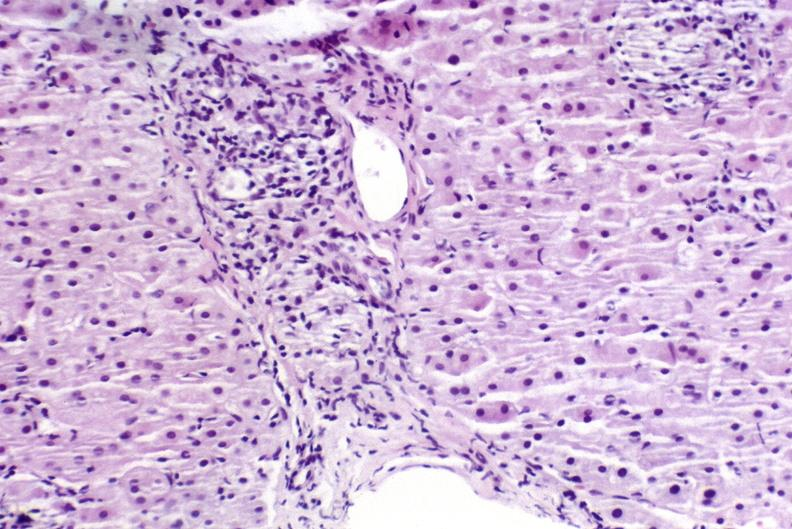s hepatobiliary present?
Answer the question using a single word or phrase. Yes 